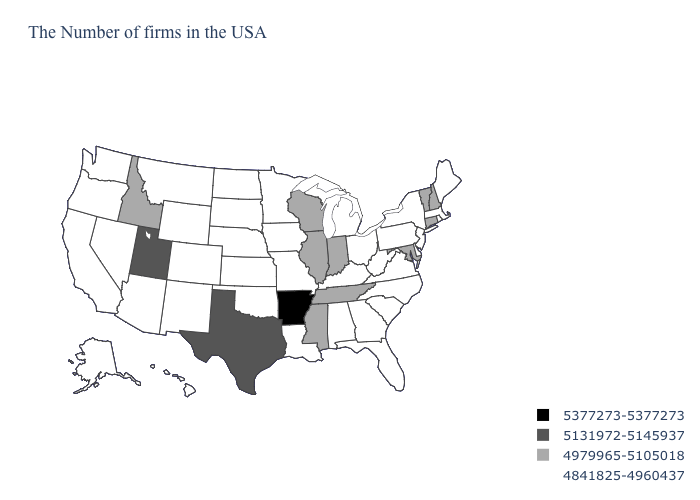What is the value of Arizona?
Short answer required. 4841825-4960437. What is the highest value in states that border West Virginia?
Be succinct. 4979965-5105018. What is the value of Delaware?
Answer briefly. 4841825-4960437. Name the states that have a value in the range 5131972-5145937?
Answer briefly. Texas, Utah. Among the states that border California , which have the highest value?
Be succinct. Arizona, Nevada, Oregon. Name the states that have a value in the range 4979965-5105018?
Short answer required. New Hampshire, Vermont, Connecticut, Maryland, Indiana, Tennessee, Wisconsin, Illinois, Mississippi, Idaho. Name the states that have a value in the range 5131972-5145937?
Keep it brief. Texas, Utah. What is the value of Maine?
Write a very short answer. 4841825-4960437. Does the map have missing data?
Short answer required. No. Which states have the lowest value in the Northeast?
Short answer required. Maine, Massachusetts, Rhode Island, New York, New Jersey, Pennsylvania. Among the states that border Nevada , which have the highest value?
Write a very short answer. Utah. Name the states that have a value in the range 5377273-5377273?
Write a very short answer. Arkansas. What is the value of Iowa?
Answer briefly. 4841825-4960437. What is the highest value in the MidWest ?
Quick response, please. 4979965-5105018. 